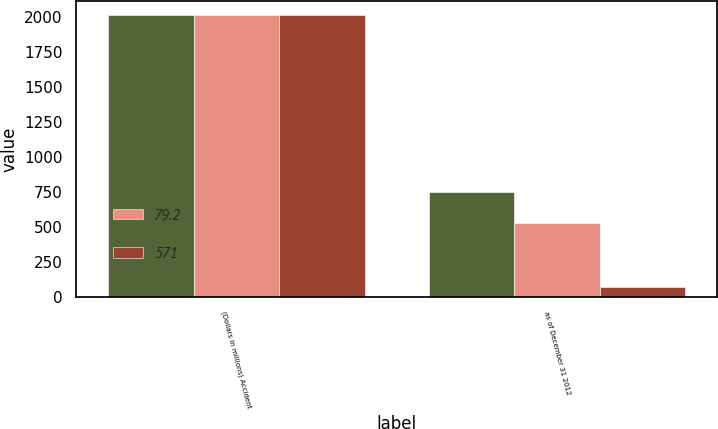Convert chart to OTSL. <chart><loc_0><loc_0><loc_500><loc_500><stacked_bar_chart><ecel><fcel>(Dollars in millions) Accident<fcel>as of December 31 2012<nl><fcel>nan<fcel>2012<fcel>751<nl><fcel>79.2<fcel>2010<fcel>529<nl><fcel>571<fcel>2010<fcel>73.4<nl></chart> 